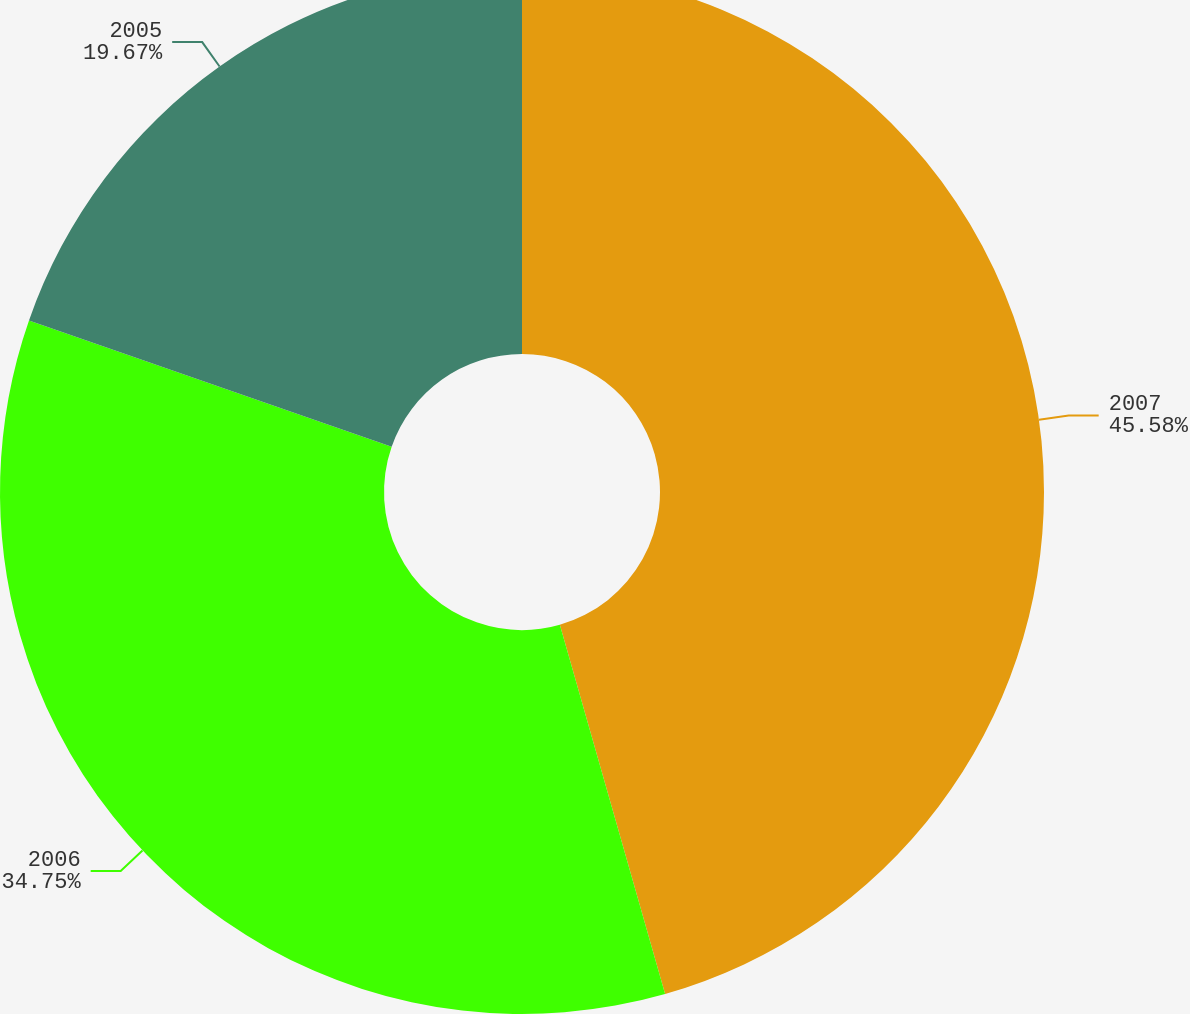<chart> <loc_0><loc_0><loc_500><loc_500><pie_chart><fcel>2007<fcel>2006<fcel>2005<nl><fcel>45.58%<fcel>34.75%<fcel>19.67%<nl></chart> 